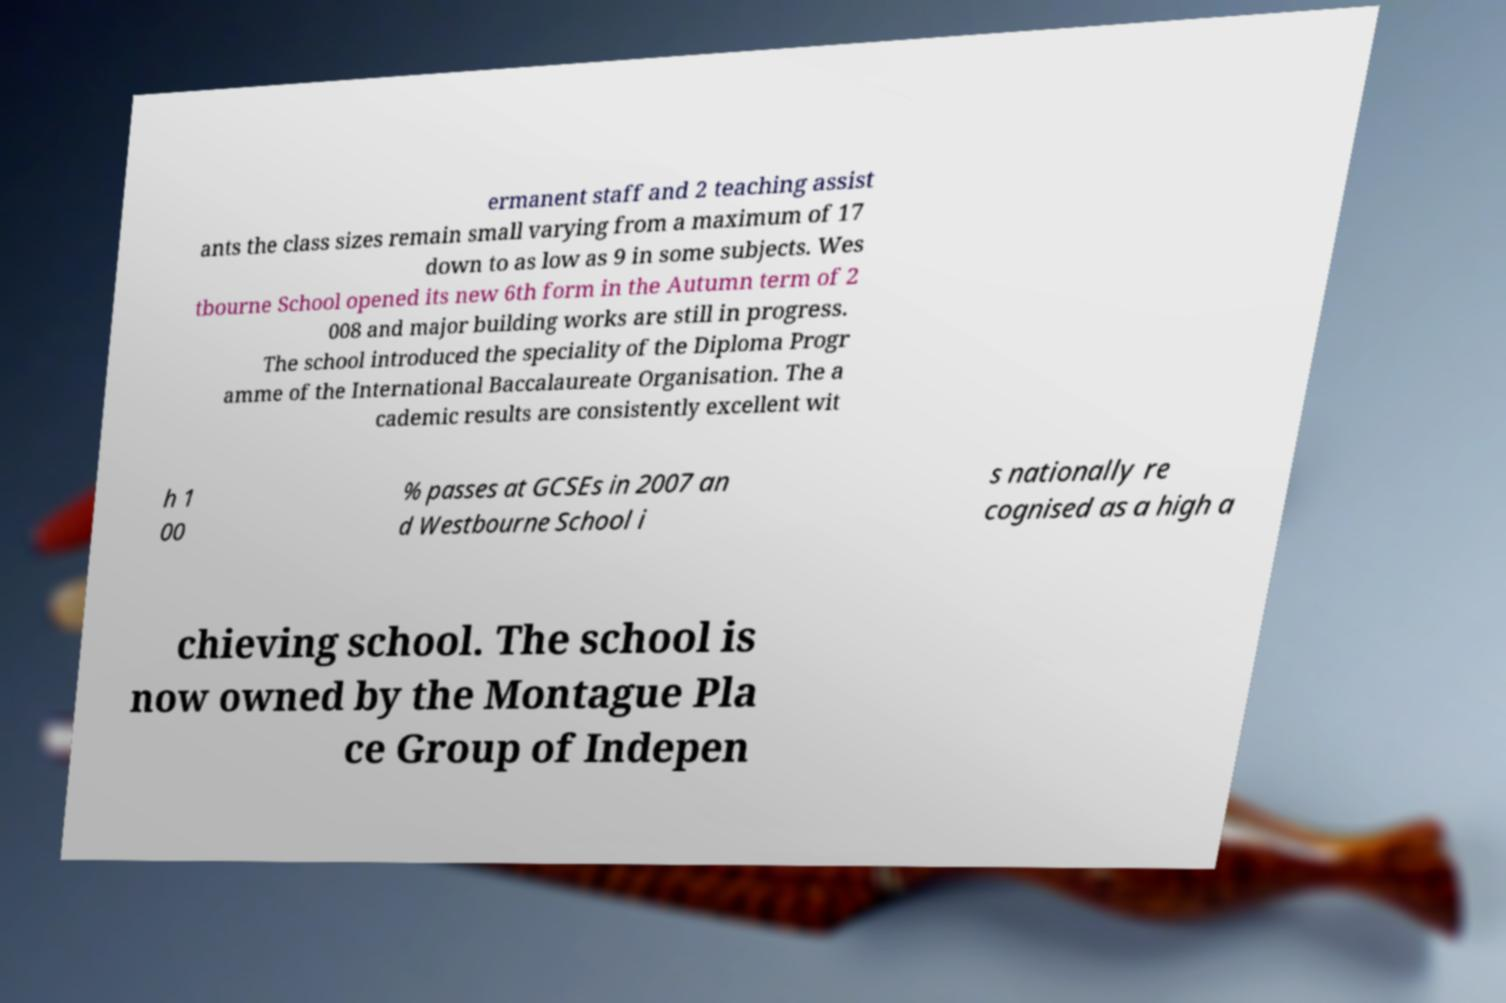Please identify and transcribe the text found in this image. ermanent staff and 2 teaching assist ants the class sizes remain small varying from a maximum of 17 down to as low as 9 in some subjects. Wes tbourne School opened its new 6th form in the Autumn term of 2 008 and major building works are still in progress. The school introduced the speciality of the Diploma Progr amme of the International Baccalaureate Organisation. The a cademic results are consistently excellent wit h 1 00 % passes at GCSEs in 2007 an d Westbourne School i s nationally re cognised as a high a chieving school. The school is now owned by the Montague Pla ce Group of Indepen 